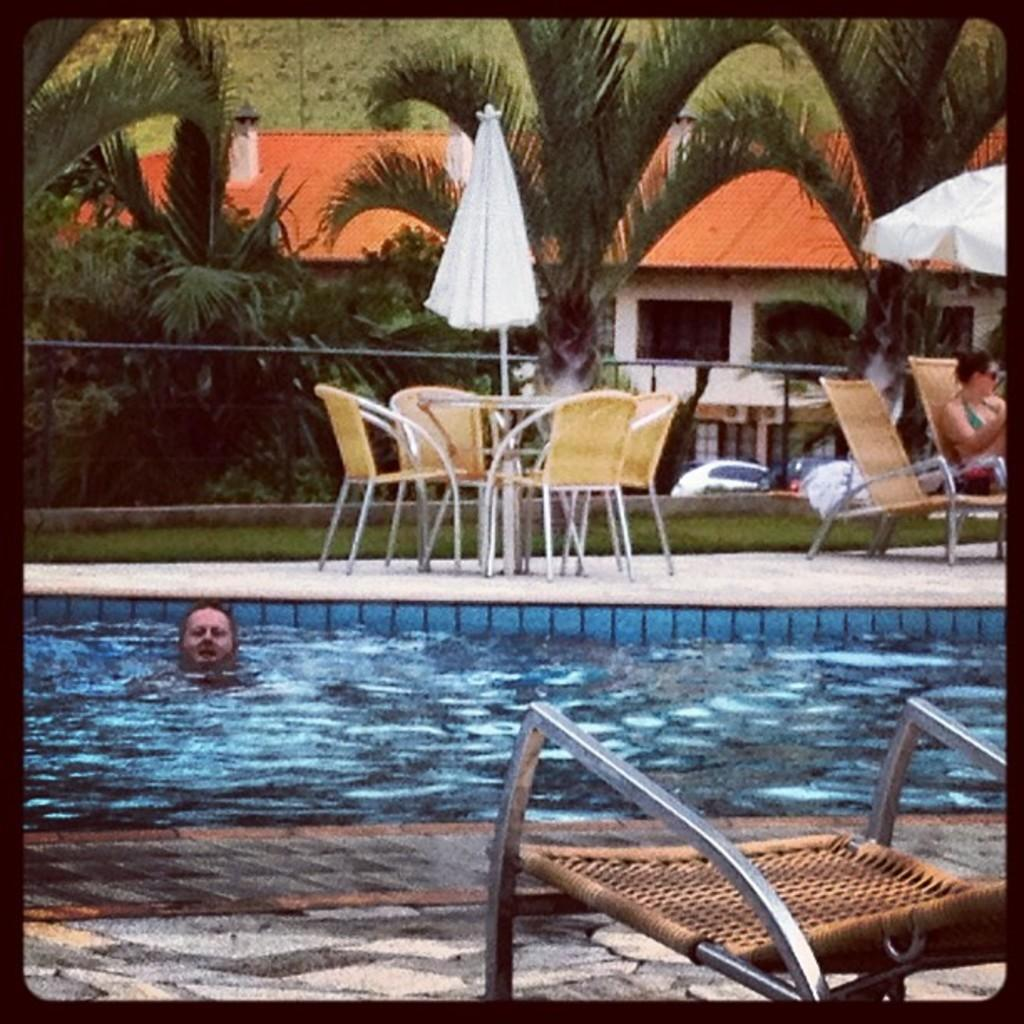What type of furniture is present in the image? There are chairs and tables in the image. Can you describe the person's position in the image? There is a person sitting on a chair in the image. What activity is the other person engaged in? There is a person swimming in a pool in the image. What objects are present to provide shade? There are umbrellas in the image. What can be seen in the background of the image? There are trees and a house in the background of the image. What type of machine is being used by the girl in the image? There is no girl present in the image, and no machine is visible. Is there a gun visible in the image? No, there is no gun present in the image. 